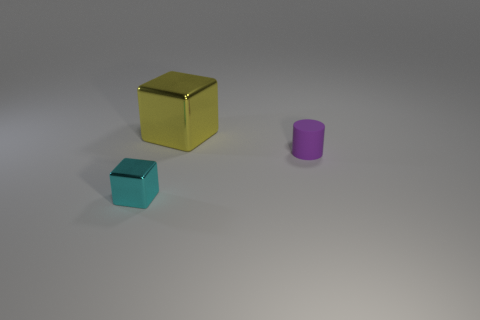Do the thing that is behind the small purple cylinder and the cube in front of the big metallic cube have the same material?
Provide a succinct answer. Yes. What shape is the thing that is both to the left of the small cylinder and behind the small metallic cube?
Make the answer very short. Cube. There is a block that is behind the metal object that is on the left side of the large cube; what is it made of?
Your response must be concise. Metal. Is the number of small metallic objects greater than the number of cyan rubber cylinders?
Ensure brevity in your answer.  Yes. There is a cyan thing that is the same size as the rubber cylinder; what is it made of?
Offer a very short reply. Metal. Is the small cyan cube made of the same material as the large object?
Ensure brevity in your answer.  Yes. How many small purple cylinders have the same material as the big object?
Your answer should be very brief. 0. What number of objects are small things that are to the left of the yellow shiny cube or metallic objects in front of the yellow shiny thing?
Provide a succinct answer. 1. Are there more yellow shiny things that are to the right of the small cyan shiny object than small purple rubber cylinders behind the large yellow metallic block?
Offer a terse response. Yes. What color is the block behind the small cyan metallic cube?
Offer a very short reply. Yellow. 